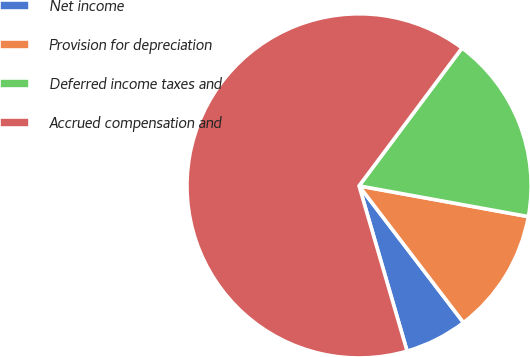<chart> <loc_0><loc_0><loc_500><loc_500><pie_chart><fcel>Net income<fcel>Provision for depreciation<fcel>Deferred income taxes and<fcel>Accrued compensation and<nl><fcel>5.88%<fcel>11.76%<fcel>17.65%<fcel>64.71%<nl></chart> 